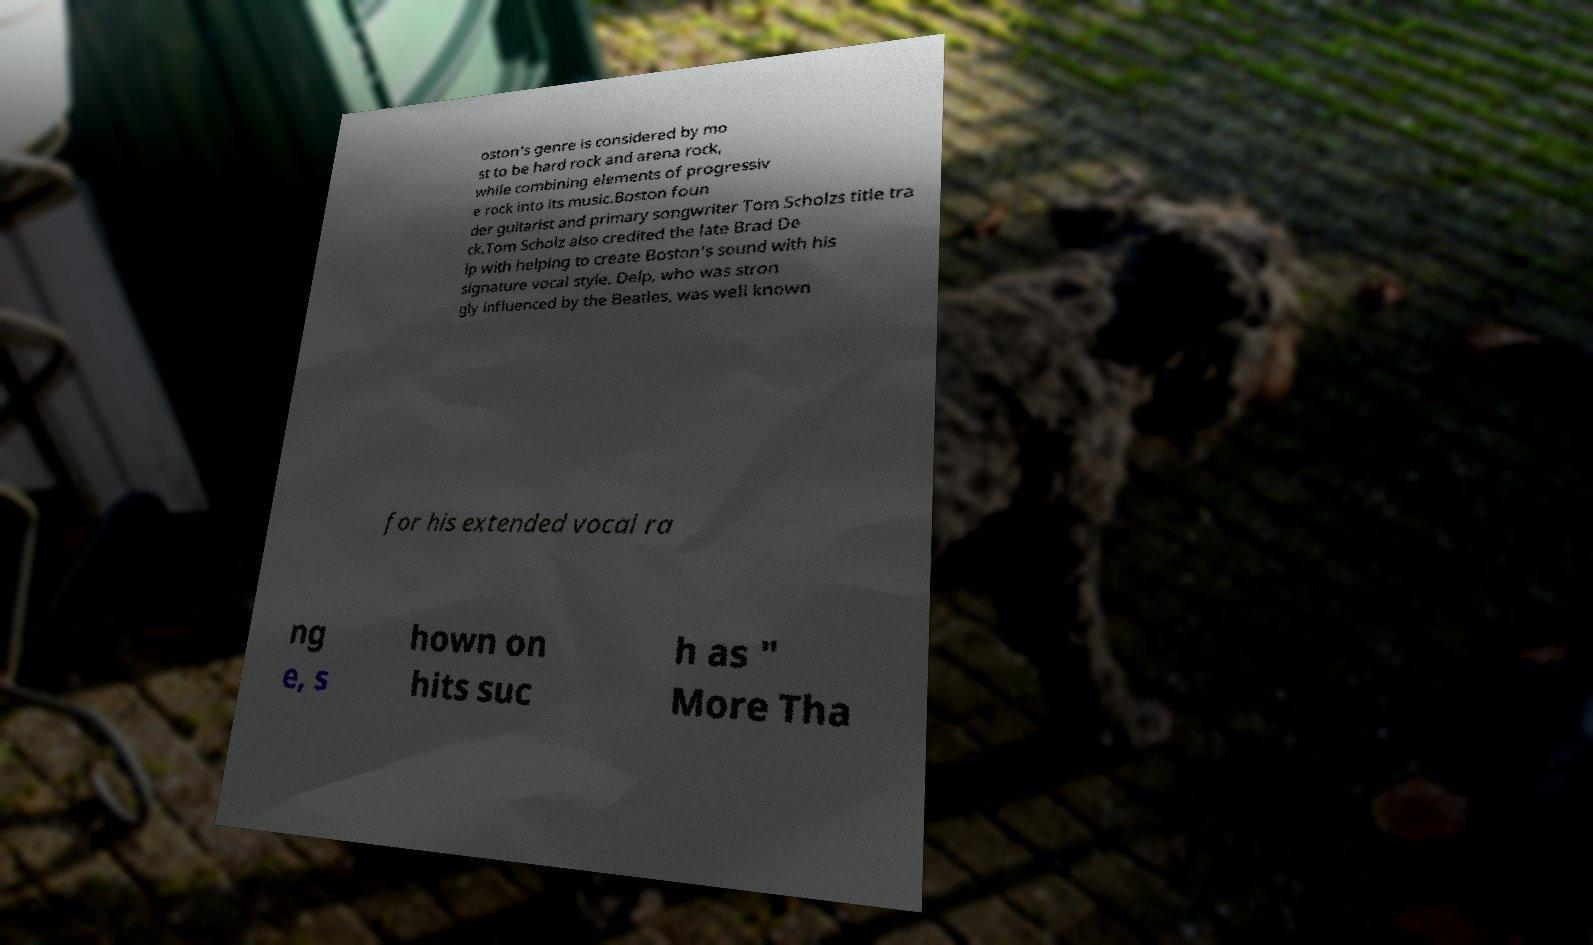For documentation purposes, I need the text within this image transcribed. Could you provide that? oston's genre is considered by mo st to be hard rock and arena rock, while combining elements of progressiv e rock into its music.Boston foun der guitarist and primary songwriter Tom Scholzs title tra ck.Tom Scholz also credited the late Brad De lp with helping to create Boston's sound with his signature vocal style. Delp, who was stron gly influenced by the Beatles, was well known for his extended vocal ra ng e, s hown on hits suc h as " More Tha 